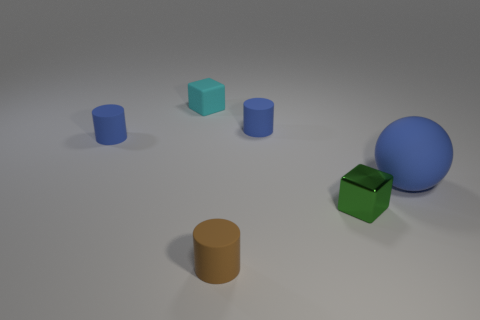Is there anything else that has the same material as the green object?
Offer a very short reply. No. There is a matte cylinder right of the small matte thing that is in front of the green cube; what is its size?
Your response must be concise. Small. Is the number of small rubber blocks that are in front of the tiny green metallic object the same as the number of big blue balls in front of the big thing?
Your answer should be compact. Yes. What is the small thing that is both on the right side of the cyan block and behind the tiny green metallic thing made of?
Give a very brief answer. Rubber. Do the cyan object and the cylinder that is in front of the tiny green shiny cube have the same size?
Make the answer very short. Yes. How many other objects are the same color as the shiny block?
Offer a very short reply. 0. Is the number of tiny green things that are behind the big rubber object greater than the number of red metallic blocks?
Your answer should be very brief. No. What color is the small cube in front of the blue matte thing that is in front of the cylinder that is on the left side of the small cyan block?
Your answer should be very brief. Green. Do the small cyan cube and the large object have the same material?
Your answer should be very brief. Yes. Is there a green metal object of the same size as the green block?
Ensure brevity in your answer.  No. 